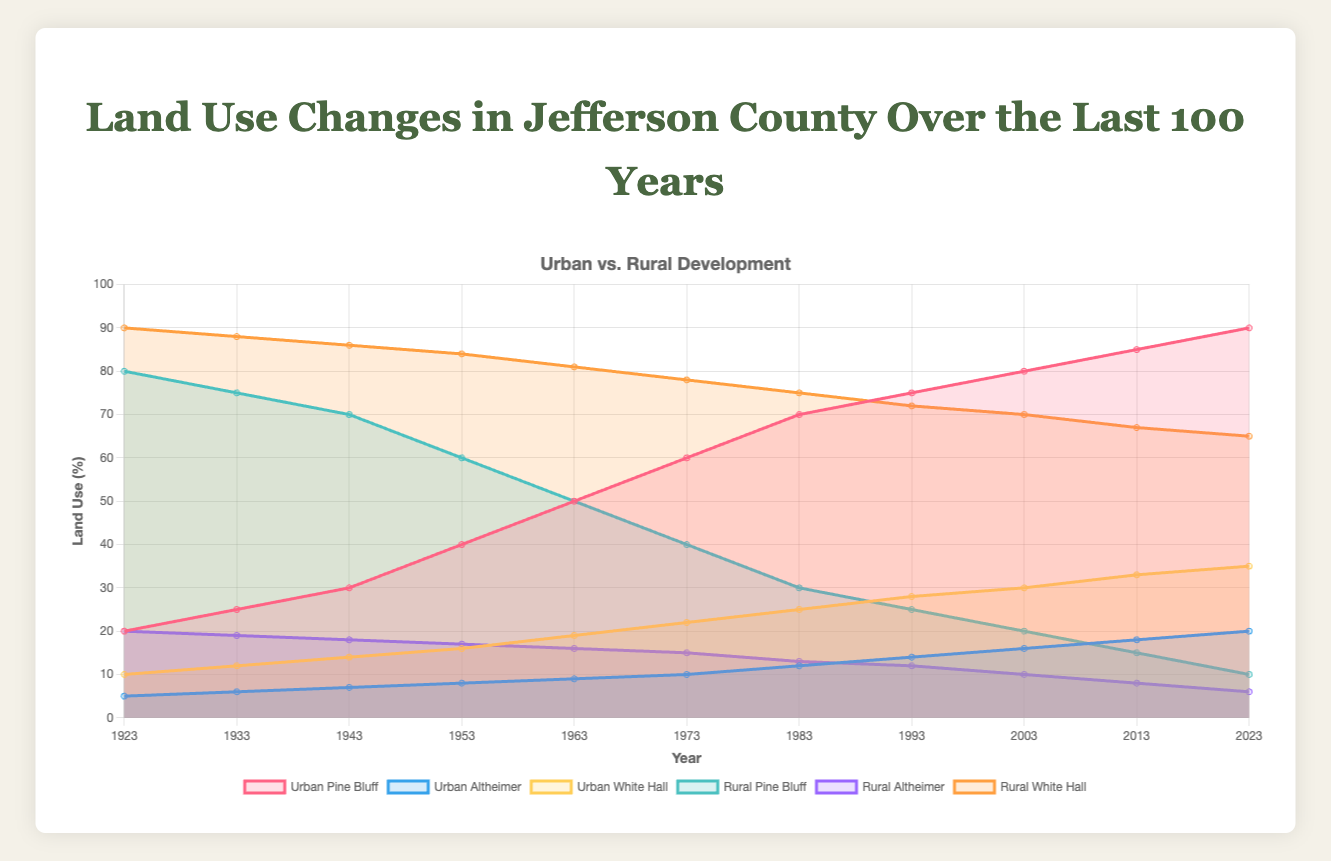What is the title of the figure? The title of the figure is prominently displayed at the top, reading "Land Use Changes in Jefferson County Over the Last 100 Years".
Answer: Land Use Changes in Jefferson County Over the Last 100 Years How many years of data are displayed in the figure? The x-axis of the chart lists years starting from 1923 to 2023, and counting them shows there are 11 data points.
Answer: 11 Which town shows the most significant increase in urban areas over the last 100 years? Pine Bluff shows the most significant increase in urban areas, growing from 20% in 1923 to 90% in 2023, as indicated by the area under the red line.
Answer: Pine Bluff Comparing 1923 and 2023, which town shows the highest percentage decrease in rural land use? Pine Bluff shows the highest percentage decrease in rural land use, dropping from 80% in 1923 to 10% in 2023, visible by the green section diminishing significantly.
Answer: Pine Bluff What was the percentage of urban land use in Altheimer in 1953? By locating the blue line (Altheimer urban) at the 1953 mark on the x-axis, it shows that urban land use in Altheimer was 8%.
Answer: 8% Which town experienced the least change in rural land use over the last 100 years? Altheimer experienced the least change, with rural land use only decreasing from 20% in 1923 to 6% in 2023, as indicated by the purple section.
Answer: Altheimer How does the urban development in White Hall in 1983 compare to that in 1943? Comparing the yellow line at 1983 and 1943 on the x-axis, White Hall's urban development increased from 14% in 1943 to 25% in 1983.
Answer: Increased by 11% What was the average percentage of rural land use in Pine Bluff over the last century? Adding the rural percentages for Pine Bluff (80, 75, 70, 60, 50, 40, 30, 25, 20, 15, 10) and dividing by 11, the average is (80 + 75 + 70 + 60 + 50 + 40 + 30 + 25 + 20 + 15 + 10) / 11 = 43.18%.
Answer: 43.18% During which decade did White Hall first exceed 50% urban land use? Following the yellow line, White Hall's urban land use first exceeds 50% between 2013 and 2023.
Answer: Between 2013 and 2023 